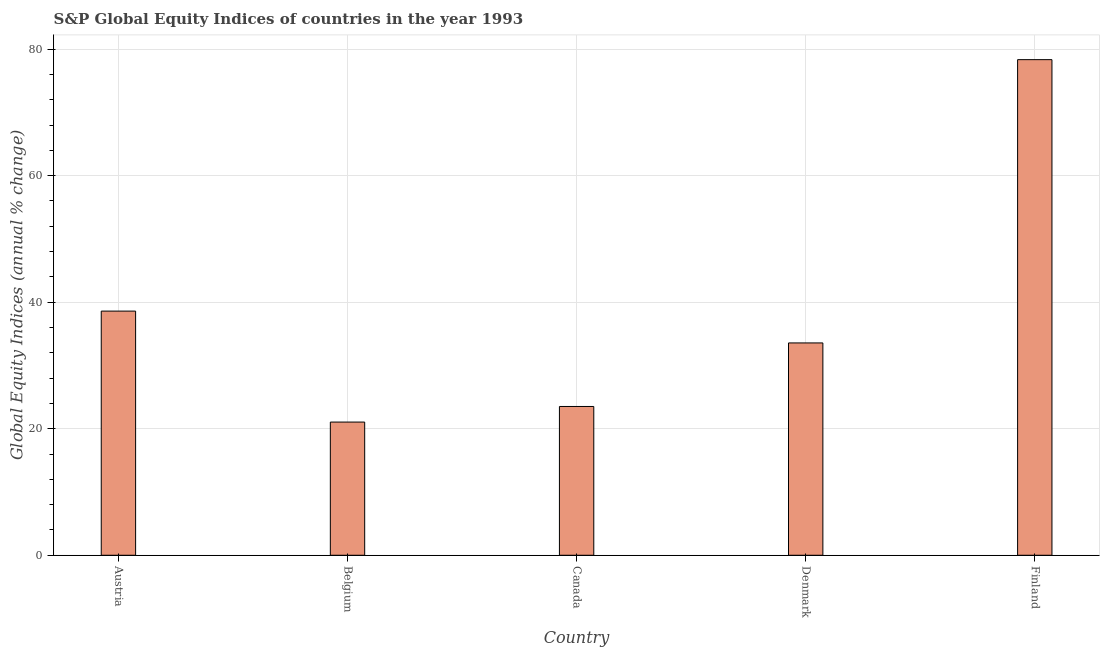Does the graph contain any zero values?
Offer a terse response. No. What is the title of the graph?
Keep it short and to the point. S&P Global Equity Indices of countries in the year 1993. What is the label or title of the X-axis?
Provide a succinct answer. Country. What is the label or title of the Y-axis?
Offer a terse response. Global Equity Indices (annual % change). What is the s&p global equity indices in Finland?
Offer a very short reply. 78.33. Across all countries, what is the maximum s&p global equity indices?
Your answer should be very brief. 78.33. Across all countries, what is the minimum s&p global equity indices?
Provide a short and direct response. 21.05. In which country was the s&p global equity indices maximum?
Ensure brevity in your answer.  Finland. What is the sum of the s&p global equity indices?
Your answer should be compact. 195.04. What is the difference between the s&p global equity indices in Belgium and Finland?
Your response must be concise. -57.28. What is the average s&p global equity indices per country?
Ensure brevity in your answer.  39.01. What is the median s&p global equity indices?
Give a very brief answer. 33.56. What is the ratio of the s&p global equity indices in Denmark to that in Finland?
Your answer should be compact. 0.43. What is the difference between the highest and the second highest s&p global equity indices?
Offer a very short reply. 39.74. Is the sum of the s&p global equity indices in Belgium and Finland greater than the maximum s&p global equity indices across all countries?
Keep it short and to the point. Yes. What is the difference between the highest and the lowest s&p global equity indices?
Keep it short and to the point. 57.28. In how many countries, is the s&p global equity indices greater than the average s&p global equity indices taken over all countries?
Keep it short and to the point. 1. How many bars are there?
Give a very brief answer. 5. Are all the bars in the graph horizontal?
Offer a terse response. No. What is the difference between two consecutive major ticks on the Y-axis?
Your answer should be very brief. 20. Are the values on the major ticks of Y-axis written in scientific E-notation?
Make the answer very short. No. What is the Global Equity Indices (annual % change) of Austria?
Offer a terse response. 38.59. What is the Global Equity Indices (annual % change) in Belgium?
Offer a very short reply. 21.05. What is the Global Equity Indices (annual % change) of Canada?
Your response must be concise. 23.52. What is the Global Equity Indices (annual % change) in Denmark?
Your answer should be very brief. 33.56. What is the Global Equity Indices (annual % change) in Finland?
Ensure brevity in your answer.  78.33. What is the difference between the Global Equity Indices (annual % change) in Austria and Belgium?
Provide a short and direct response. 17.54. What is the difference between the Global Equity Indices (annual % change) in Austria and Canada?
Provide a short and direct response. 15.07. What is the difference between the Global Equity Indices (annual % change) in Austria and Denmark?
Provide a succinct answer. 5.03. What is the difference between the Global Equity Indices (annual % change) in Austria and Finland?
Make the answer very short. -39.74. What is the difference between the Global Equity Indices (annual % change) in Belgium and Canada?
Your answer should be compact. -2.47. What is the difference between the Global Equity Indices (annual % change) in Belgium and Denmark?
Make the answer very short. -12.51. What is the difference between the Global Equity Indices (annual % change) in Belgium and Finland?
Ensure brevity in your answer.  -57.28. What is the difference between the Global Equity Indices (annual % change) in Canada and Denmark?
Provide a short and direct response. -10.04. What is the difference between the Global Equity Indices (annual % change) in Canada and Finland?
Ensure brevity in your answer.  -54.81. What is the difference between the Global Equity Indices (annual % change) in Denmark and Finland?
Your response must be concise. -44.77. What is the ratio of the Global Equity Indices (annual % change) in Austria to that in Belgium?
Make the answer very short. 1.83. What is the ratio of the Global Equity Indices (annual % change) in Austria to that in Canada?
Provide a short and direct response. 1.64. What is the ratio of the Global Equity Indices (annual % change) in Austria to that in Denmark?
Give a very brief answer. 1.15. What is the ratio of the Global Equity Indices (annual % change) in Austria to that in Finland?
Your response must be concise. 0.49. What is the ratio of the Global Equity Indices (annual % change) in Belgium to that in Canada?
Keep it short and to the point. 0.9. What is the ratio of the Global Equity Indices (annual % change) in Belgium to that in Denmark?
Ensure brevity in your answer.  0.63. What is the ratio of the Global Equity Indices (annual % change) in Belgium to that in Finland?
Your response must be concise. 0.27. What is the ratio of the Global Equity Indices (annual % change) in Canada to that in Denmark?
Provide a succinct answer. 0.7. What is the ratio of the Global Equity Indices (annual % change) in Denmark to that in Finland?
Keep it short and to the point. 0.43. 